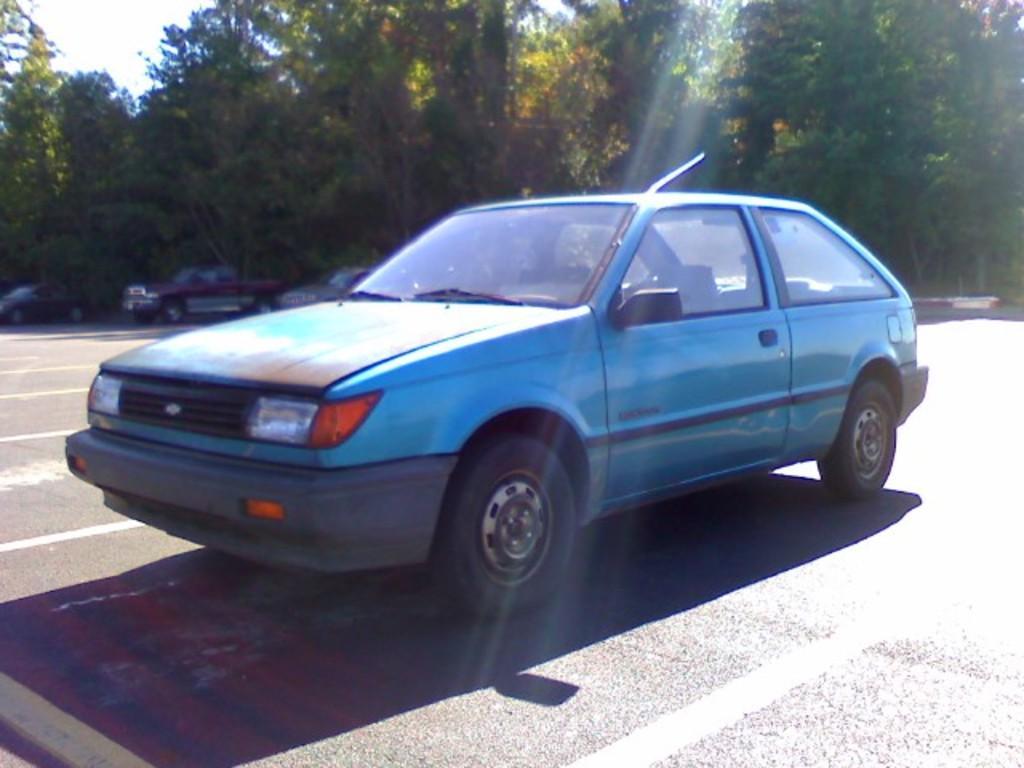How would you summarize this image in a sentence or two? In this image, I can see the cars, which are parked. These are the trees with branches and leaves. 